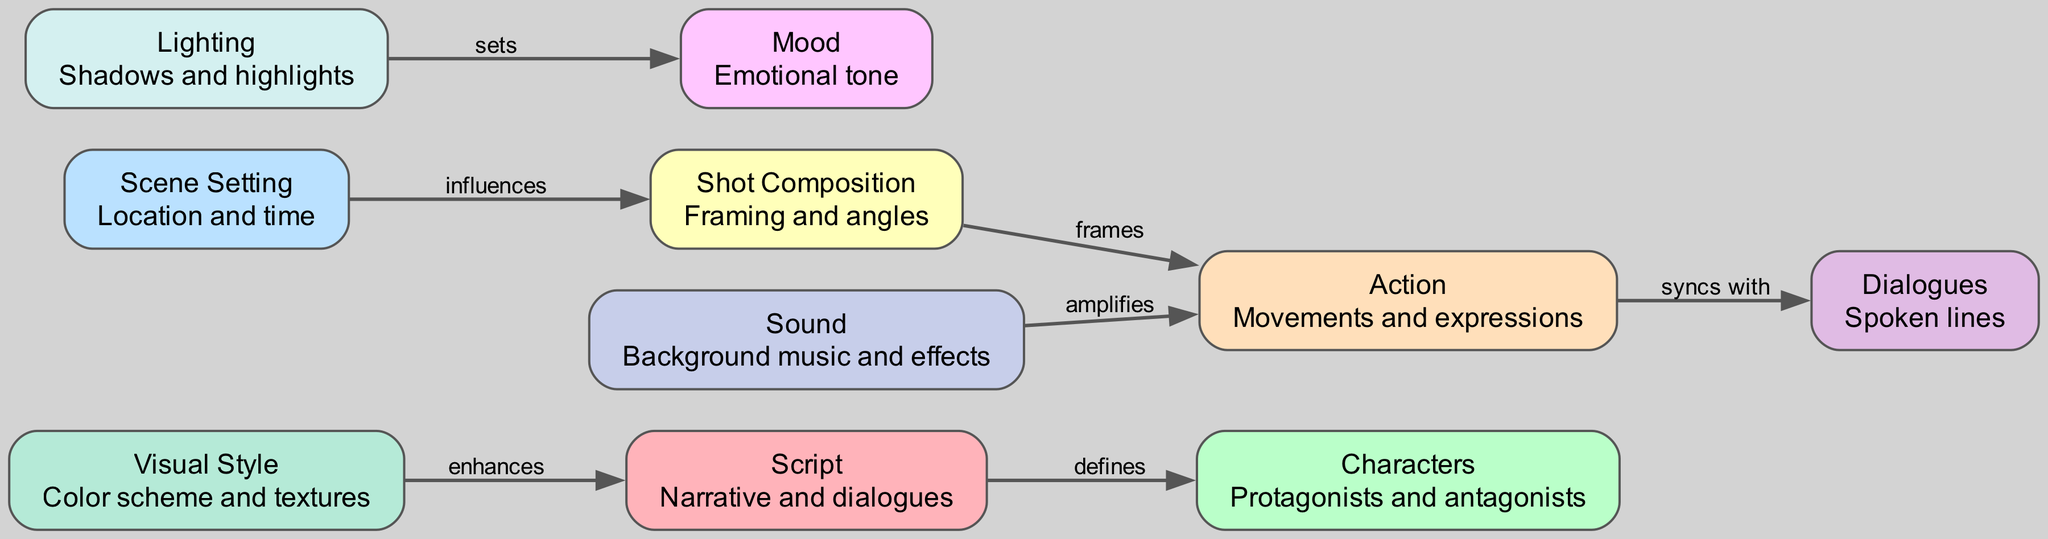What is the label of node 3? Node 3 has the label "Scene Setting" which is indicated in the diagram.
Answer: Scene Setting How many total nodes are in the diagram? The diagram lists a total of ten nodes, each representing a key element in storyboarding.
Answer: 10 What relationship does "Lighting" have with "Mood"? The diagram shows that "Lighting" sets the "Mood," which indicates the influence it has on the emotional tone of the scene.
Answer: sets Which node frames "Action"? The diagram clearly shows that "Shot Composition" frames "Action," as indicated by the arrow connecting the two.
Answer: Shot Composition What does "Visual Style" enhance? According to the diagram, "Visual Style" enhances the "Script," suggesting that the visual design complements the narrative and dialogues.
Answer: Script What is the relationship between "Action" and "Dialogues"? The relationship described in the diagram is that "Action" syncs with "Dialogues," meaning they are coordinated in timing and expression.
Answer: syncs with Which two nodes influence each other? The diagram indicates that "Scene Setting" influences "Shot Composition," demonstrating that the setting informs how the shot is framed.
Answer: Scene Setting, Shot Composition How many edges are in the diagram? There are a total of six edges, each representing a relationship between the different nodes in the diagram.
Answer: 6 What is the description of node 5? The description of node 5 is "Movements and expressions," detailing its focus within the storyboarding context.
Answer: Movements and expressions 